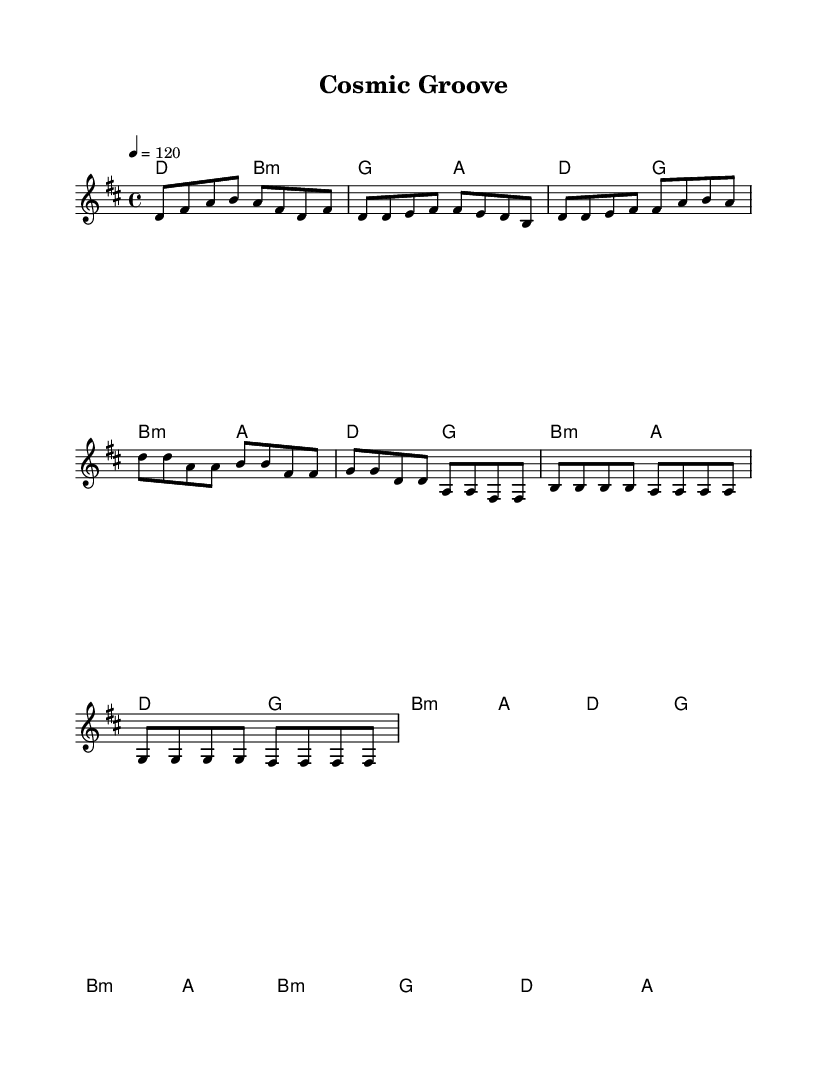what is the key signature of this music? The key signature is D major, which has two sharps: F# and C#. This can be identified at the beginning of the sheet music where the key signature is indicated.
Answer: D major what is the time signature of this music? The time signature is 4/4, which is indicated at the beginning of the piece. This means there are four beats in a measure and a quarter note receives one beat.
Answer: 4/4 what is the tempo marking? The tempo marking is indicated as 120 beats per minute, written in the measure above the music. This indicates the speed at which the piece should be played.
Answer: 120 how many measures are there in the melody section? By visually counting each grouping in the melody section, there are a total of 8 measures present, including the intro, verses, chorus, and bridge.
Answer: 8 what is the first chord in the harmonies? The first chord in the harmonies is D major, which can be seen located in the introductory section of the harmonies. This is established from the chord symbols given at the beginning of the score.
Answer: D what is the pattern of the verse in terms of melody notes? The verse melody follows a pattern of alternating notes: d, e, and f# play a role while repeating notes like d and f# create a sense of movement. This can be discerned by analyzing the sequence of notes within the verse.
Answer: alternating notes which section of the music has a repeated chord sequence? The chorus of the song features a repeated chord sequence using the same chords: D major, G major, B minor, and A major throughout the section, creating a consistent harmonic foundation.
Answer: chorus 